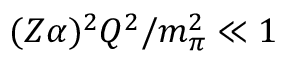Convert formula to latex. <formula><loc_0><loc_0><loc_500><loc_500>( Z \alpha ) ^ { 2 } Q ^ { 2 } / m _ { \pi } ^ { 2 } \ll 1</formula> 